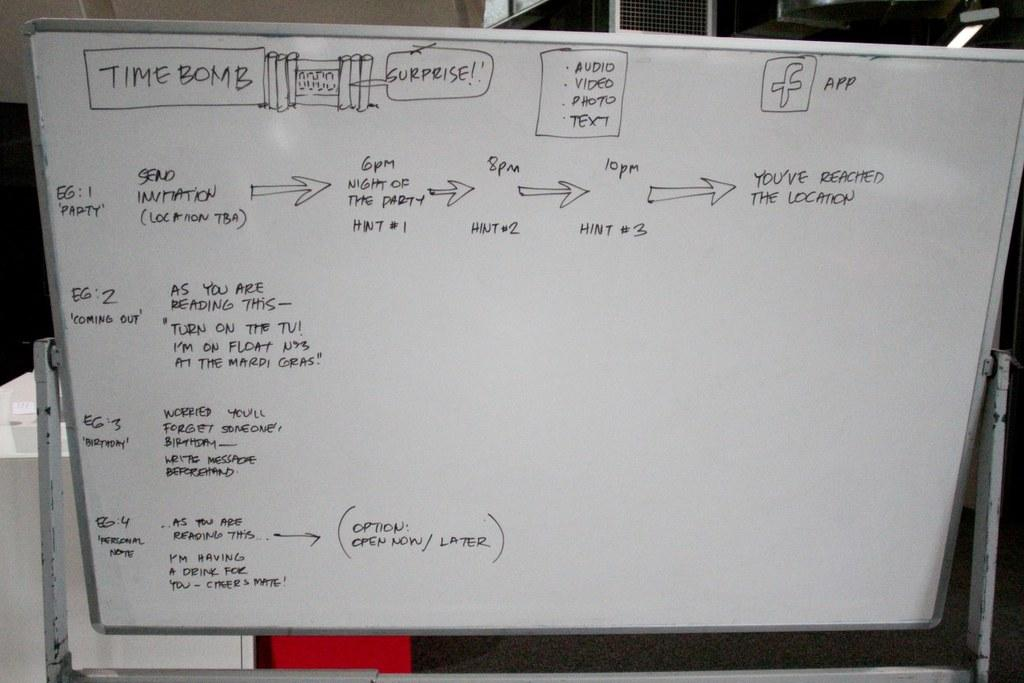<image>
Write a terse but informative summary of the picture. the words time bomb that is on a white board 